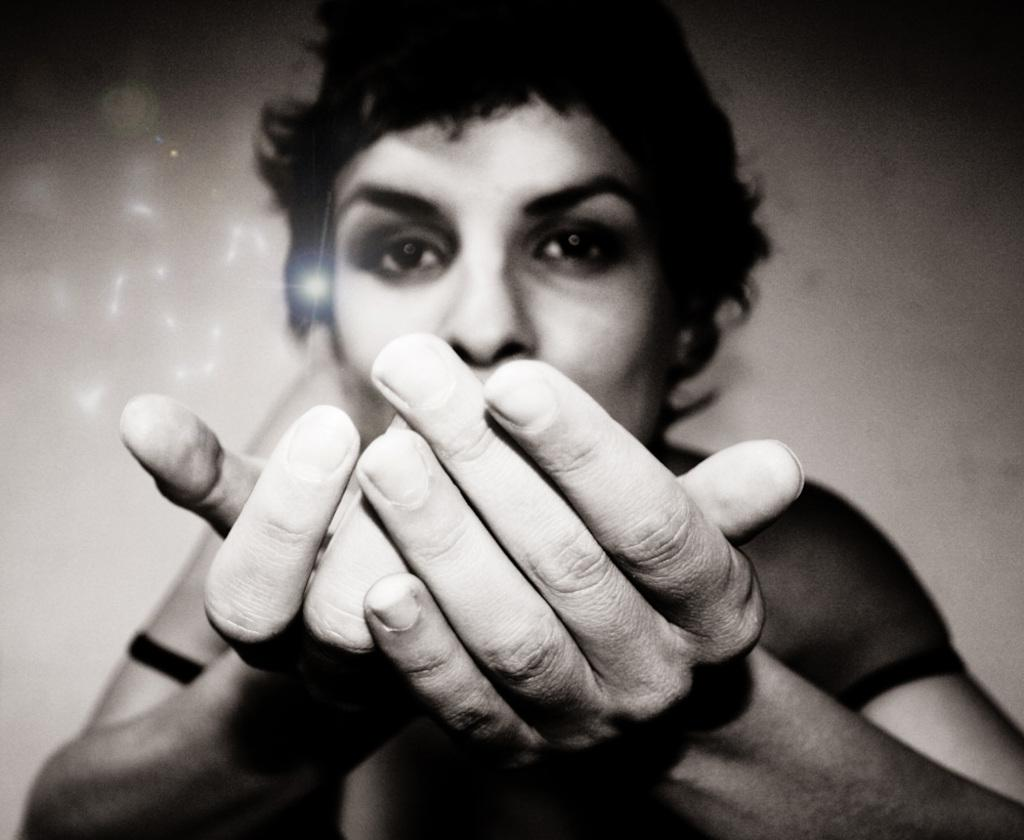What is the color scheme of the image? The image is black and white. Can you describe the main subject in the image? There is a person in the image. What additional detail can be observed on the left side of the image? There are sparkles on the left side of the image. How many sisters does the person in the image have? There is no information about the person's sisters in the image. What type of pail is visible in the image? There is no pail present in the image. 